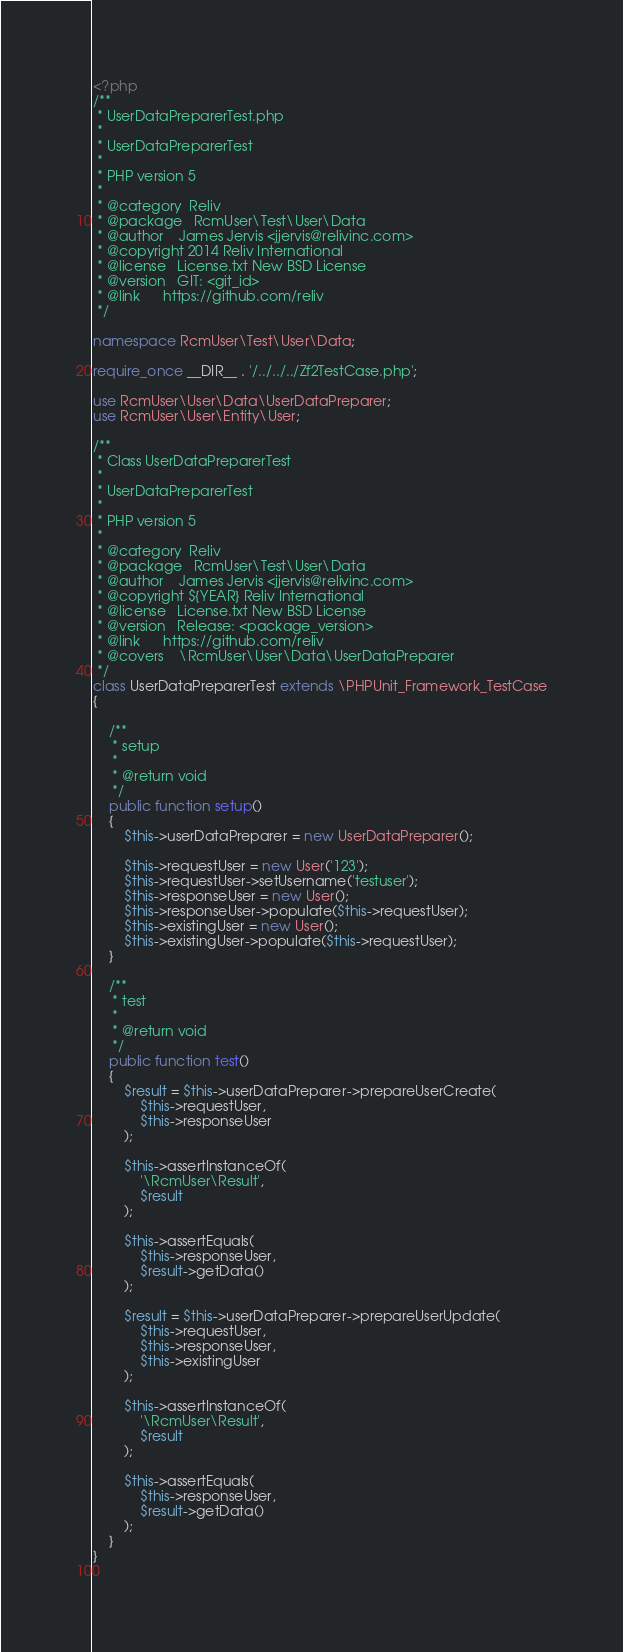Convert code to text. <code><loc_0><loc_0><loc_500><loc_500><_PHP_><?php
/**
 * UserDataPreparerTest.php
 *
 * UserDataPreparerTest
 *
 * PHP version 5
 *
 * @category  Reliv
 * @package   RcmUser\Test\User\Data
 * @author    James Jervis <jjervis@relivinc.com>
 * @copyright 2014 Reliv International
 * @license   License.txt New BSD License
 * @version   GIT: <git_id>
 * @link      https://github.com/reliv
 */

namespace RcmUser\Test\User\Data;

require_once __DIR__ . '/../../../Zf2TestCase.php';

use RcmUser\User\Data\UserDataPreparer;
use RcmUser\User\Entity\User;

/**
 * Class UserDataPreparerTest
 *
 * UserDataPreparerTest
 *
 * PHP version 5
 *
 * @category  Reliv
 * @package   RcmUser\Test\User\Data
 * @author    James Jervis <jjervis@relivinc.com>
 * @copyright ${YEAR} Reliv International
 * @license   License.txt New BSD License
 * @version   Release: <package_version>
 * @link      https://github.com/reliv
 * @covers    \RcmUser\User\Data\UserDataPreparer
 */
class UserDataPreparerTest extends \PHPUnit_Framework_TestCase
{

    /**
     * setup
     *
     * @return void
     */
    public function setup()
    {
        $this->userDataPreparer = new UserDataPreparer();

        $this->requestUser = new User('123');
        $this->requestUser->setUsername('testuser');
        $this->responseUser = new User();
        $this->responseUser->populate($this->requestUser);
        $this->existingUser = new User();
        $this->existingUser->populate($this->requestUser);
    }

    /**
     * test
     *
     * @return void
     */
    public function test()
    {
        $result = $this->userDataPreparer->prepareUserCreate(
            $this->requestUser,
            $this->responseUser
        );

        $this->assertInstanceOf(
            '\RcmUser\Result',
            $result
        );

        $this->assertEquals(
            $this->responseUser,
            $result->getData()
        );

        $result = $this->userDataPreparer->prepareUserUpdate(
            $this->requestUser,
            $this->responseUser,
            $this->existingUser
        );

        $this->assertInstanceOf(
            '\RcmUser\Result',
            $result
        );

        $this->assertEquals(
            $this->responseUser,
            $result->getData()
        );
    }
}
 </code> 